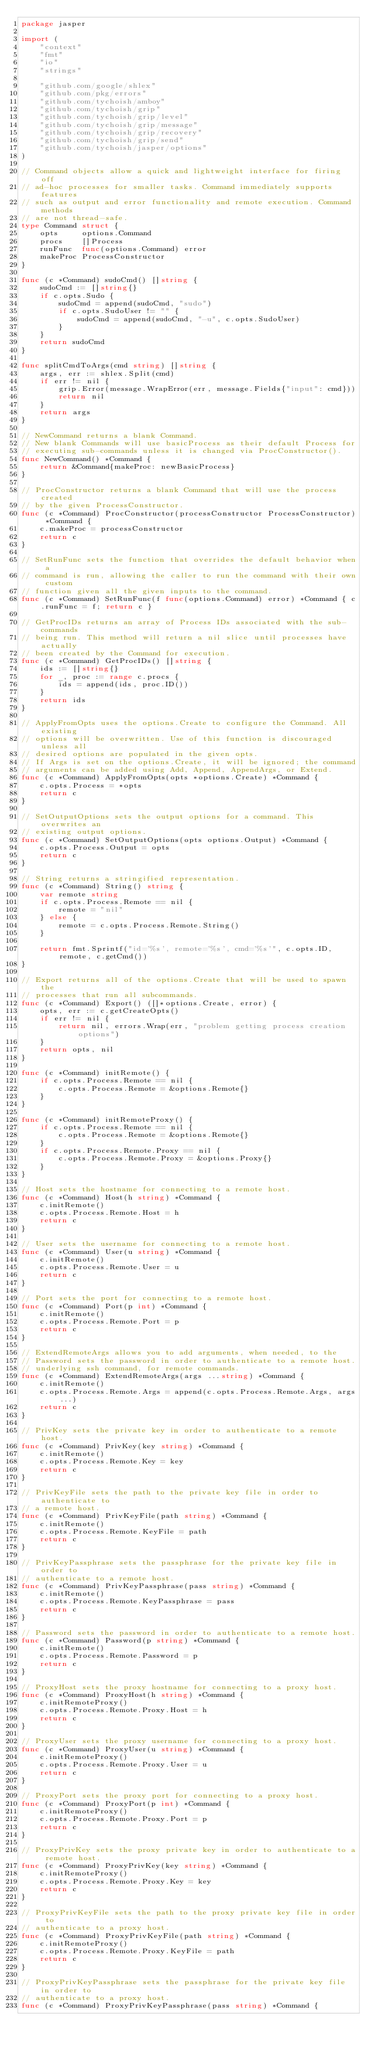<code> <loc_0><loc_0><loc_500><loc_500><_Go_>package jasper

import (
	"context"
	"fmt"
	"io"
	"strings"

	"github.com/google/shlex"
	"github.com/pkg/errors"
	"github.com/tychoish/amboy"
	"github.com/tychoish/grip"
	"github.com/tychoish/grip/level"
	"github.com/tychoish/grip/message"
	"github.com/tychoish/grip/recovery"
	"github.com/tychoish/grip/send"
	"github.com/tychoish/jasper/options"
)

// Command objects allow a quick and lightweight interface for firing off
// ad-hoc processes for smaller tasks. Command immediately supports features
// such as output and error functionality and remote execution. Command methods
// are not thread-safe.
type Command struct {
	opts     options.Command
	procs    []Process
	runFunc  func(options.Command) error
	makeProc ProcessConstructor
}

func (c *Command) sudoCmd() []string {
	sudoCmd := []string{}
	if c.opts.Sudo {
		sudoCmd = append(sudoCmd, "sudo")
		if c.opts.SudoUser != "" {
			sudoCmd = append(sudoCmd, "-u", c.opts.SudoUser)
		}
	}
	return sudoCmd
}

func splitCmdToArgs(cmd string) []string {
	args, err := shlex.Split(cmd)
	if err != nil {
		grip.Error(message.WrapError(err, message.Fields{"input": cmd}))
		return nil
	}
	return args
}

// NewCommand returns a blank Command.
// New blank Commands will use basicProcess as their default Process for
// executing sub-commands unless it is changed via ProcConstructor().
func NewCommand() *Command {
	return &Command{makeProc: newBasicProcess}
}

// ProcConstructor returns a blank Command that will use the process created
// by the given ProcessConstructor.
func (c *Command) ProcConstructor(processConstructor ProcessConstructor) *Command {
	c.makeProc = processConstructor
	return c
}

// SetRunFunc sets the function that overrides the default behavior when a
// command is run, allowing the caller to run the command with their own custom
// function given all the given inputs to the command.
func (c *Command) SetRunFunc(f func(options.Command) error) *Command { c.runFunc = f; return c }

// GetProcIDs returns an array of Process IDs associated with the sub-commands
// being run. This method will return a nil slice until processes have actually
// been created by the Command for execution.
func (c *Command) GetProcIDs() []string {
	ids := []string{}
	for _, proc := range c.procs {
		ids = append(ids, proc.ID())
	}
	return ids
}

// ApplyFromOpts uses the options.Create to configure the Command. All existing
// options will be overwritten. Use of this function is discouraged unless all
// desired options are populated in the given opts.
// If Args is set on the options.Create, it will be ignored; the command
// arguments can be added using Add, Append, AppendArgs, or Extend.
func (c *Command) ApplyFromOpts(opts *options.Create) *Command {
	c.opts.Process = *opts
	return c
}

// SetOutputOptions sets the output options for a command. This overwrites an
// existing output options.
func (c *Command) SetOutputOptions(opts options.Output) *Command {
	c.opts.Process.Output = opts
	return c
}

// String returns a stringified representation.
func (c *Command) String() string {
	var remote string
	if c.opts.Process.Remote == nil {
		remote = "nil"
	} else {
		remote = c.opts.Process.Remote.String()
	}

	return fmt.Sprintf("id='%s', remote='%s', cmd='%s'", c.opts.ID, remote, c.getCmd())
}

// Export returns all of the options.Create that will be used to spawn the
// processes that run all subcommands.
func (c *Command) Export() ([]*options.Create, error) {
	opts, err := c.getCreateOpts()
	if err != nil {
		return nil, errors.Wrap(err, "problem getting process creation options")
	}
	return opts, nil
}

func (c *Command) initRemote() {
	if c.opts.Process.Remote == nil {
		c.opts.Process.Remote = &options.Remote{}
	}
}

func (c *Command) initRemoteProxy() {
	if c.opts.Process.Remote == nil {
		c.opts.Process.Remote = &options.Remote{}
	}
	if c.opts.Process.Remote.Proxy == nil {
		c.opts.Process.Remote.Proxy = &options.Proxy{}
	}
}

// Host sets the hostname for connecting to a remote host.
func (c *Command) Host(h string) *Command {
	c.initRemote()
	c.opts.Process.Remote.Host = h
	return c
}

// User sets the username for connecting to a remote host.
func (c *Command) User(u string) *Command {
	c.initRemote()
	c.opts.Process.Remote.User = u
	return c
}

// Port sets the port for connecting to a remote host.
func (c *Command) Port(p int) *Command {
	c.initRemote()
	c.opts.Process.Remote.Port = p
	return c
}

// ExtendRemoteArgs allows you to add arguments, when needed, to the
// Password sets the password in order to authenticate to a remote host.
// underlying ssh command, for remote commands.
func (c *Command) ExtendRemoteArgs(args ...string) *Command {
	c.initRemote()
	c.opts.Process.Remote.Args = append(c.opts.Process.Remote.Args, args...)
	return c
}

// PrivKey sets the private key in order to authenticate to a remote host.
func (c *Command) PrivKey(key string) *Command {
	c.initRemote()
	c.opts.Process.Remote.Key = key
	return c
}

// PrivKeyFile sets the path to the private key file in order to authenticate to
// a remote host.
func (c *Command) PrivKeyFile(path string) *Command {
	c.initRemote()
	c.opts.Process.Remote.KeyFile = path
	return c
}

// PrivKeyPassphrase sets the passphrase for the private key file in order to
// authenticate to a remote host.
func (c *Command) PrivKeyPassphrase(pass string) *Command {
	c.initRemote()
	c.opts.Process.Remote.KeyPassphrase = pass
	return c
}

// Password sets the password in order to authenticate to a remote host.
func (c *Command) Password(p string) *Command {
	c.initRemote()
	c.opts.Process.Remote.Password = p
	return c
}

// ProxyHost sets the proxy hostname for connecting to a proxy host.
func (c *Command) ProxyHost(h string) *Command {
	c.initRemoteProxy()
	c.opts.Process.Remote.Proxy.Host = h
	return c
}

// ProxyUser sets the proxy username for connecting to a proxy host.
func (c *Command) ProxyUser(u string) *Command {
	c.initRemoteProxy()
	c.opts.Process.Remote.Proxy.User = u
	return c
}

// ProxyPort sets the proxy port for connecting to a proxy host.
func (c *Command) ProxyPort(p int) *Command {
	c.initRemoteProxy()
	c.opts.Process.Remote.Proxy.Port = p
	return c
}

// ProxyPrivKey sets the proxy private key in order to authenticate to a remote host.
func (c *Command) ProxyPrivKey(key string) *Command {
	c.initRemoteProxy()
	c.opts.Process.Remote.Proxy.Key = key
	return c
}

// ProxyPrivKeyFile sets the path to the proxy private key file in order to
// authenticate to a proxy host.
func (c *Command) ProxyPrivKeyFile(path string) *Command {
	c.initRemoteProxy()
	c.opts.Process.Remote.Proxy.KeyFile = path
	return c
}

// ProxyPrivKeyPassphrase sets the passphrase for the private key file in order to
// authenticate to a proxy host.
func (c *Command) ProxyPrivKeyPassphrase(pass string) *Command {</code> 